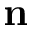Convert formula to latex. <formula><loc_0><loc_0><loc_500><loc_500>{ n }</formula> 